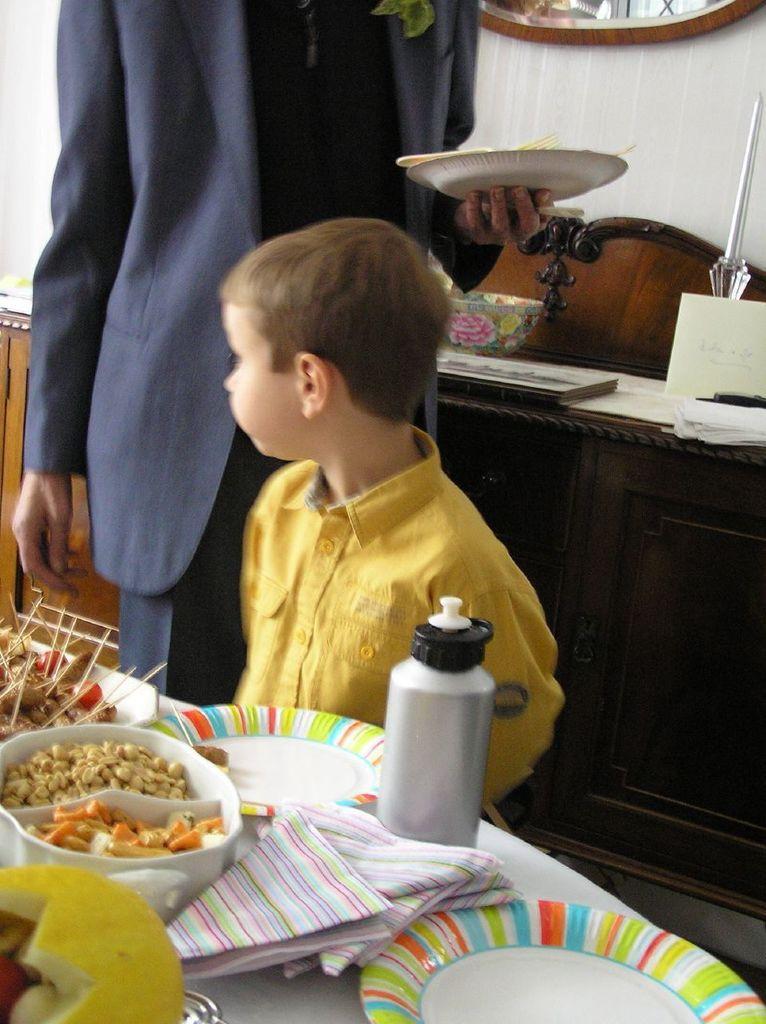Describe this image in one or two sentences. In this image I see a child and a person who is holding a plate, I can also see there is a table on which there are many things on it. In the background I see a cabinet and the wall. 